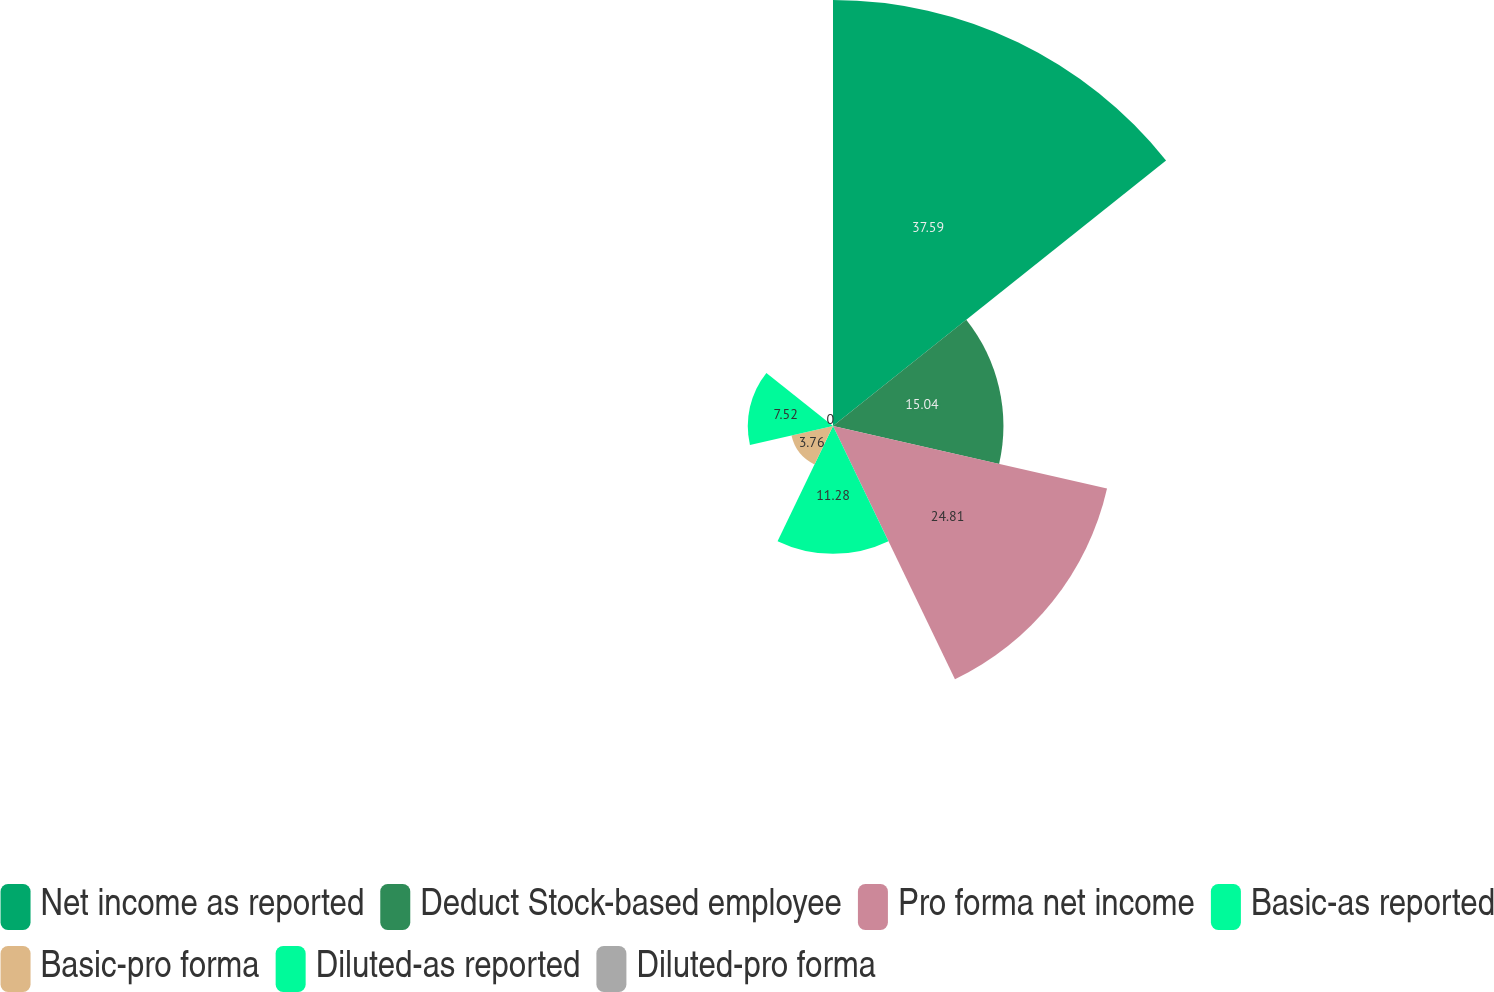Convert chart. <chart><loc_0><loc_0><loc_500><loc_500><pie_chart><fcel>Net income as reported<fcel>Deduct Stock-based employee<fcel>Pro forma net income<fcel>Basic-as reported<fcel>Basic-pro forma<fcel>Diluted-as reported<fcel>Diluted-pro forma<nl><fcel>37.6%<fcel>15.04%<fcel>24.81%<fcel>11.28%<fcel>3.76%<fcel>7.52%<fcel>0.0%<nl></chart> 